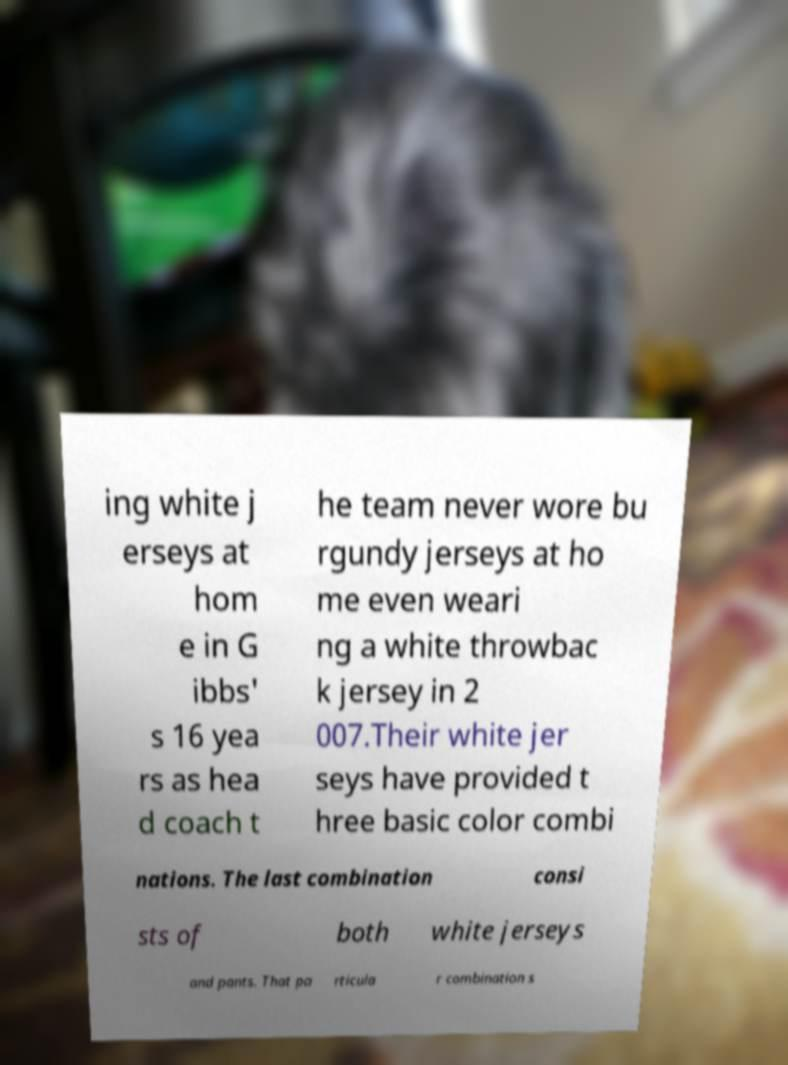For documentation purposes, I need the text within this image transcribed. Could you provide that? ing white j erseys at hom e in G ibbs' s 16 yea rs as hea d coach t he team never wore bu rgundy jerseys at ho me even weari ng a white throwbac k jersey in 2 007.Their white jer seys have provided t hree basic color combi nations. The last combination consi sts of both white jerseys and pants. That pa rticula r combination s 